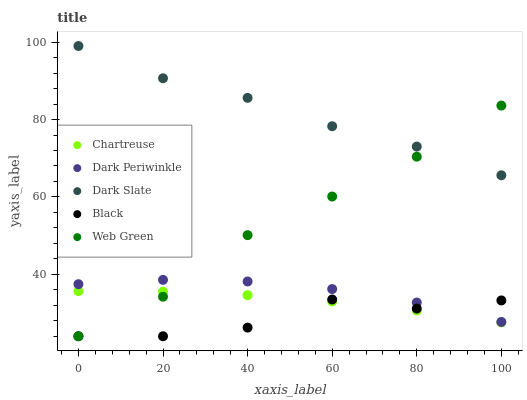Does Black have the minimum area under the curve?
Answer yes or no. Yes. Does Dark Slate have the maximum area under the curve?
Answer yes or no. Yes. Does Chartreuse have the minimum area under the curve?
Answer yes or no. No. Does Chartreuse have the maximum area under the curve?
Answer yes or no. No. Is Chartreuse the smoothest?
Answer yes or no. Yes. Is Black the roughest?
Answer yes or no. Yes. Is Black the smoothest?
Answer yes or no. No. Is Chartreuse the roughest?
Answer yes or no. No. Does Black have the lowest value?
Answer yes or no. Yes. Does Chartreuse have the lowest value?
Answer yes or no. No. Does Dark Slate have the highest value?
Answer yes or no. Yes. Does Chartreuse have the highest value?
Answer yes or no. No. Is Black less than Dark Slate?
Answer yes or no. Yes. Is Dark Periwinkle greater than Chartreuse?
Answer yes or no. Yes. Does Black intersect Chartreuse?
Answer yes or no. Yes. Is Black less than Chartreuse?
Answer yes or no. No. Is Black greater than Chartreuse?
Answer yes or no. No. Does Black intersect Dark Slate?
Answer yes or no. No. 